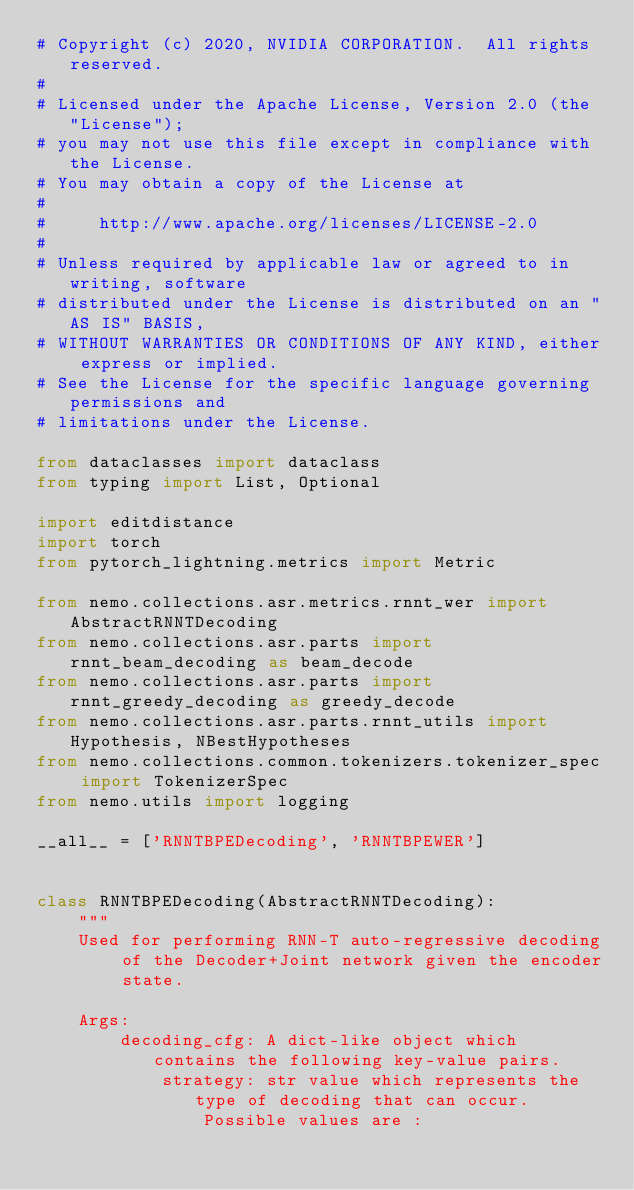<code> <loc_0><loc_0><loc_500><loc_500><_Python_># Copyright (c) 2020, NVIDIA CORPORATION.  All rights reserved.
#
# Licensed under the Apache License, Version 2.0 (the "License");
# you may not use this file except in compliance with the License.
# You may obtain a copy of the License at
#
#     http://www.apache.org/licenses/LICENSE-2.0
#
# Unless required by applicable law or agreed to in writing, software
# distributed under the License is distributed on an "AS IS" BASIS,
# WITHOUT WARRANTIES OR CONDITIONS OF ANY KIND, either express or implied.
# See the License for the specific language governing permissions and
# limitations under the License.

from dataclasses import dataclass
from typing import List, Optional

import editdistance
import torch
from pytorch_lightning.metrics import Metric

from nemo.collections.asr.metrics.rnnt_wer import AbstractRNNTDecoding
from nemo.collections.asr.parts import rnnt_beam_decoding as beam_decode
from nemo.collections.asr.parts import rnnt_greedy_decoding as greedy_decode
from nemo.collections.asr.parts.rnnt_utils import Hypothesis, NBestHypotheses
from nemo.collections.common.tokenizers.tokenizer_spec import TokenizerSpec
from nemo.utils import logging

__all__ = ['RNNTBPEDecoding', 'RNNTBPEWER']


class RNNTBPEDecoding(AbstractRNNTDecoding):
    """
    Used for performing RNN-T auto-regressive decoding of the Decoder+Joint network given the encoder state.

    Args:
        decoding_cfg: A dict-like object which contains the following key-value pairs.
            strategy: str value which represents the type of decoding that can occur.
                Possible values are :</code> 